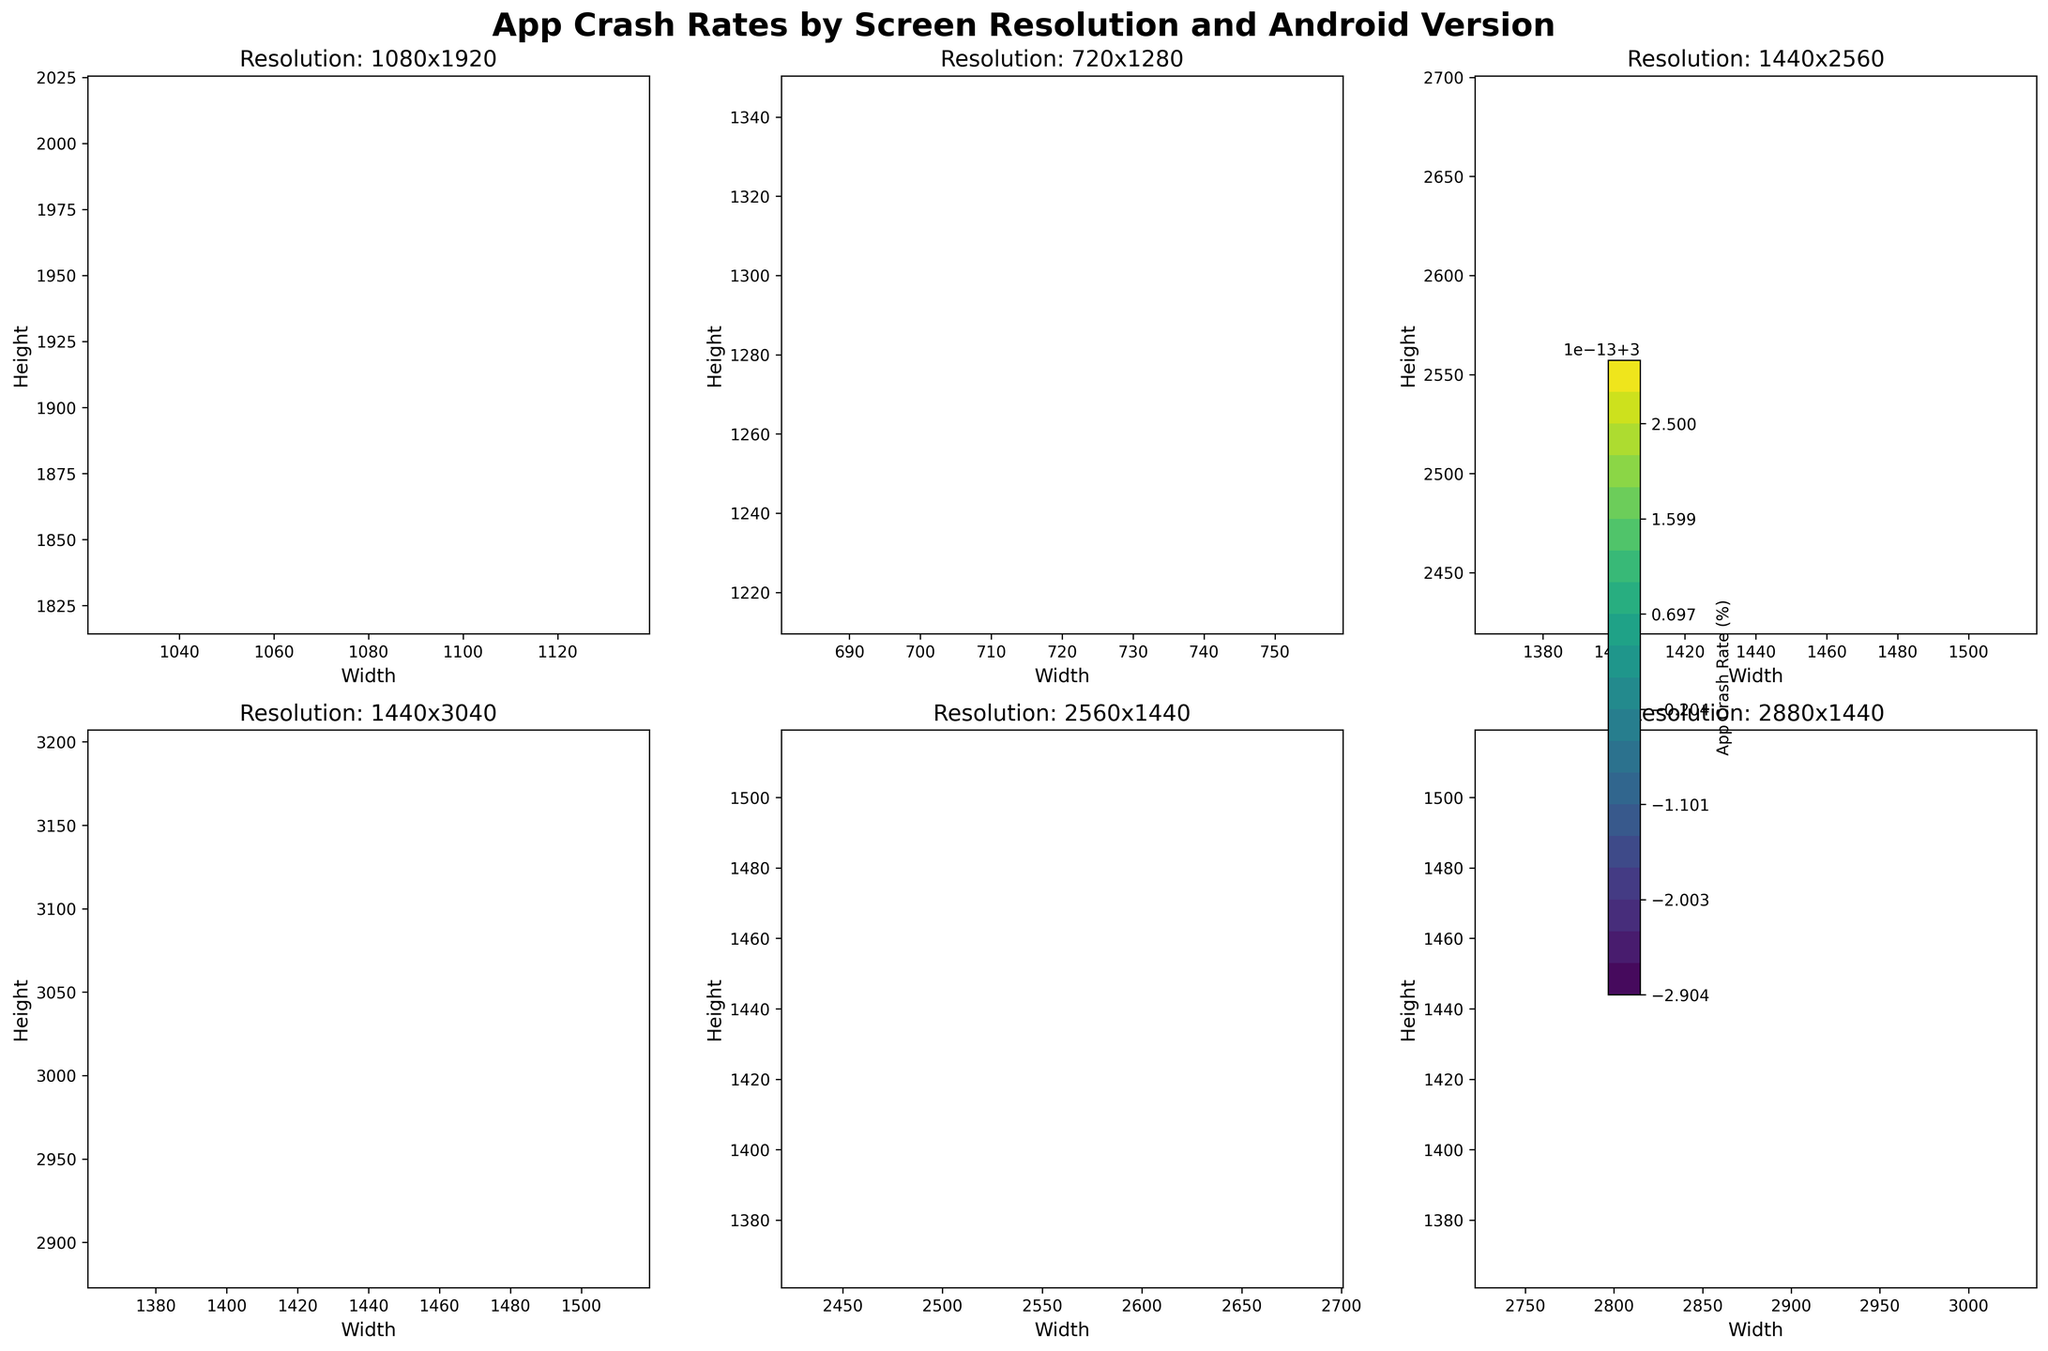What is the title of the figure? The title of the figure is prominently displayed at the top. It reads "App Crash Rates by Screen Resolution and Android Version."
Answer: App Crash Rates by Screen Resolution and Android Version Which screen resolutions are shown in the figure? By examining the subplot titles, we can see various resolutions such as 1080x1920, 720x1280, 1440x2560, 1440x3040, 2560x1440, and 2880x1440.
Answer: 1080x1920, 720x1280, 1440x2560, 1440x3040, 2560x1440, 2880x1440 What is the axis label for the x-axis and y-axis in the subplots? The x-axis is labeled 'Width' and the y-axis is labeled 'Height' in each of the subplots, indicating the dimensions of the screen resolution.
Answer: Width and Height Which OS version shows the lowest crash rate across all resolutions? By comparing the annotated crash rates, Android Version 12.0 consistently shows the lowest crash rate across all screen resolutions in each of the subplots.
Answer: Android Version 12.0 For the resolution 1080x1920, what are the crash rates for different Android versions? For the resolution 1080x1920, the crash rates are annotated in the subplot as follows: 9.0 (2.3%), 10.0 (2.1%), 11.0 (2.2%), 12.0 (2.0%).
Answer: 2.3%, 2.1%, 2.2%, 2.0% Which screen resolution has the highest app crash rate and what is it? By inspecting all subplots, the resolution 2880x1440 for Android 9.0 has the highest app crash rate, annotated as 3.5%.
Answer: 2880x1440 with 3.5% How does the crash rate change for the resolution 2560x1440 as the Android version updates from 9.0 to 12.0? For the resolution 2560x1440, as the Android version updates from 9.0 to 12.0, the crash rate decreases from 3.4% to 2.9%, showing a trend of decreasing crash rates with newer Android versions.
Answer: Decreases from 3.4% to 2.9% Which resolutions have a crash rate below 2% for Android Version 12.0? By examining the subplots for Android Version 12.0, we observe that only the resolutions 1440x2560 (1.5%) and 1440x3040 (1.6%) have crash rates below 2%.
Answer: 1440x2560 and 1440x3040 What trends can you observe about crash rates relative to screen resolution and Android version? Observing the figure, it is clear that:
1. Higher resolution screens generally have higher crash rates.
2. Newer Android versions tend to have lower crash rates across all resolutions.
3. The trend is consistent across different screen dimensions.
Answer: High resolution - higher crash rates; Newer Android versions - lower crash rates How do the crash rates for the resolution 1440x2560 compare between Android Version 9.0 and 11.0? For the resolution 1440x2560, the crash rates are 1.8% for Android 9.0 and 1.6% for Android 11.0, indicating a slight decrease over versions.
Answer: 1.8% vs. 1.6% 